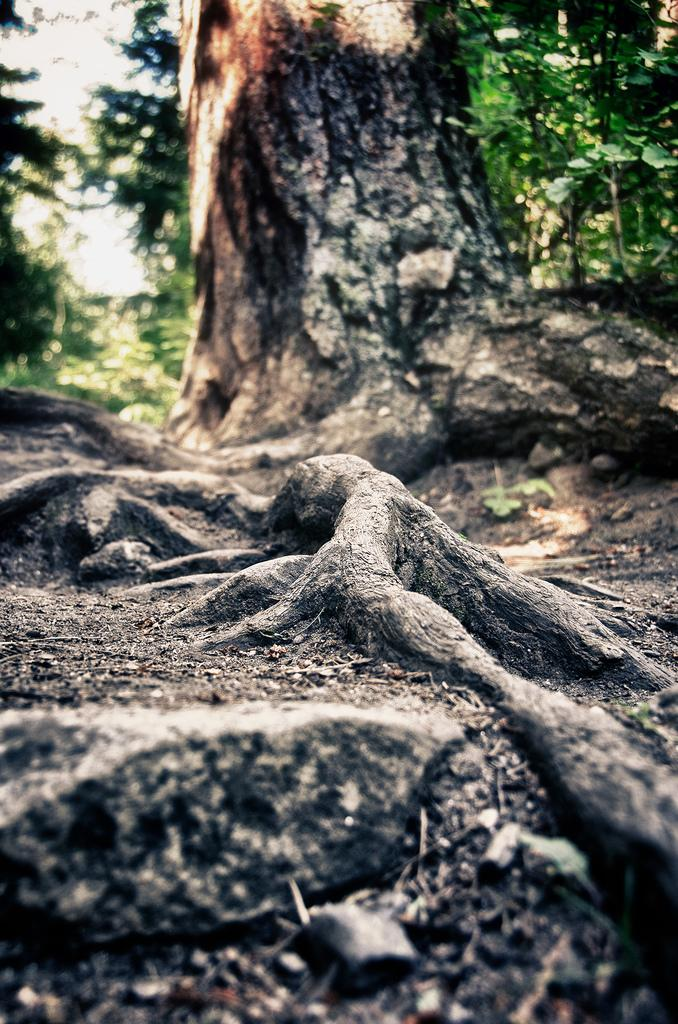What is the main subject in the front of the image? There is a tree in the front of the image. What can be seen behind the front tree in the image? There are many trees behind the front tree in the image. What type of natural element is present on the land in the image? There is a rock on the land in the image. Where are the nets located in the image? There are no nets present in the image. How many bikes can be seen in the image? There are no bikes present in the image. Is there a swing visible in the image? There is no swing present in the image. 